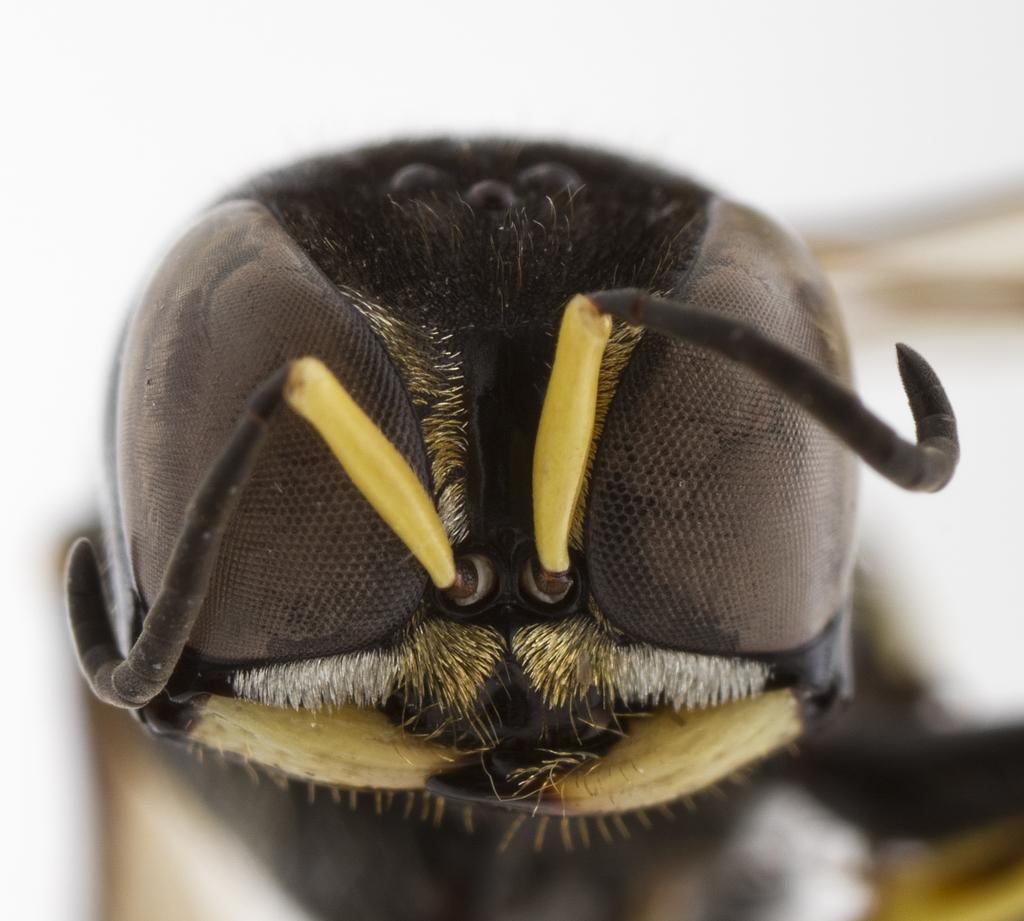What type of creature can be seen in the picture? There is an insect in the picture. What is the background of the picture? There is a white backdrop in the picture. What type of wood is the insect using to write its approval in the image? There is no wood or writing present in the image, and therefore no such activity can be observed. 